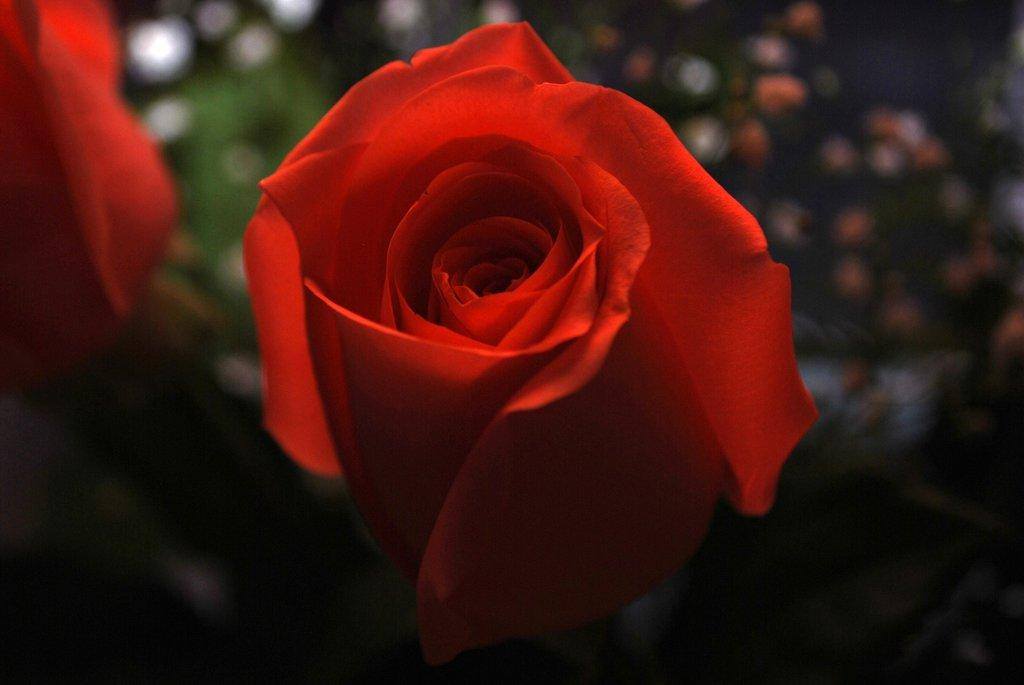What is the main subject of the image? The main subject of the image is a red color rose. How many red color roses can be seen in the image? There are two red color roses in the image. Can you describe the position of the second red color rose? The second red color rose is on the left side top of the image. What can be observed about the background of the image? The background of the image appears blurry. What type of muscle is being flexed by the vegetable in the image? There is no vegetable or muscle present in the image; it features red color roses. 